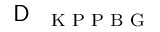<formula> <loc_0><loc_0><loc_500><loc_500>D _ { K P P B G }</formula> 